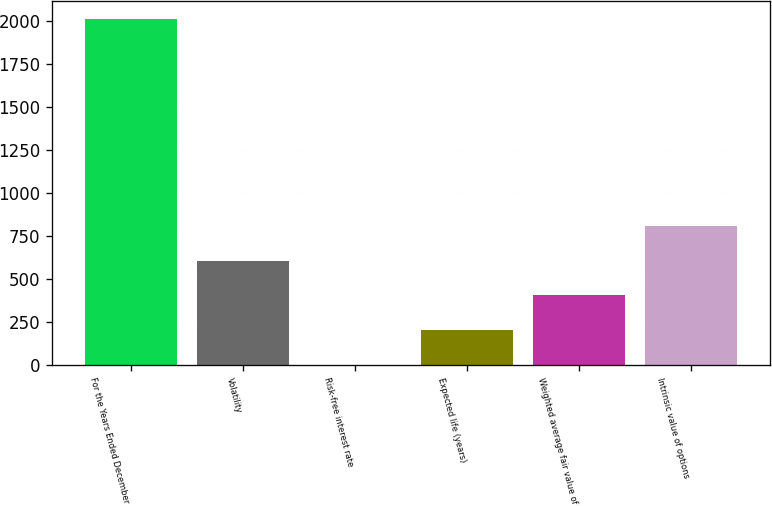Convert chart. <chart><loc_0><loc_0><loc_500><loc_500><bar_chart><fcel>For the Years Ended December<fcel>Volatility<fcel>Risk-free interest rate<fcel>Expected life (years)<fcel>Weighted average fair value of<fcel>Intrinsic value of options<nl><fcel>2011<fcel>604.84<fcel>2.2<fcel>203.08<fcel>403.96<fcel>805.72<nl></chart> 